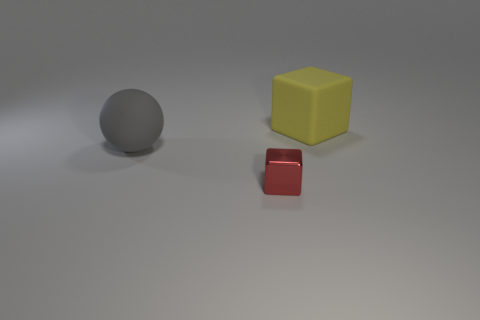There is a thing in front of the big gray ball; is its shape the same as the object right of the small metallic thing? Upon examining the image, the object in front of the big gray ball, which appears to be a red cube, does share the same geometric shape as the object to the right of the small metallic thing, which is a yellow cube. Both objects exhibit the properties of a cube: six faces, all rectangular and of equal size, along with twelve edges and eight vertices. 